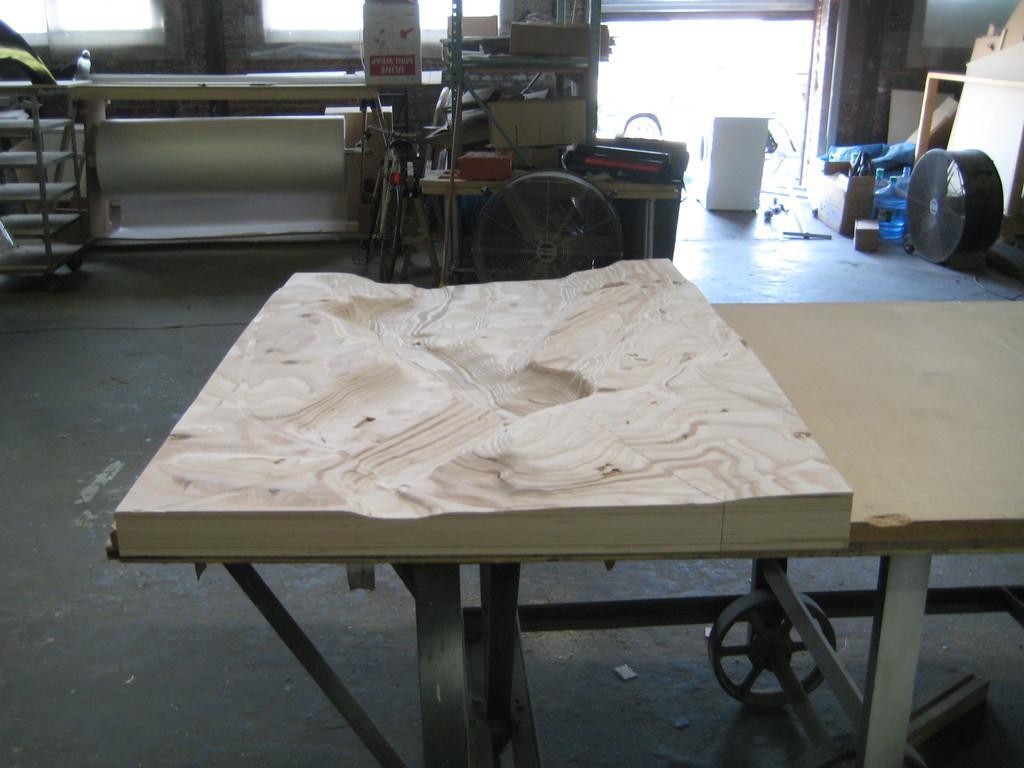In one or two sentences, can you explain what this image depicts? We can see wooden carving on the table and we can see wheels,furniture,box on the floor. 